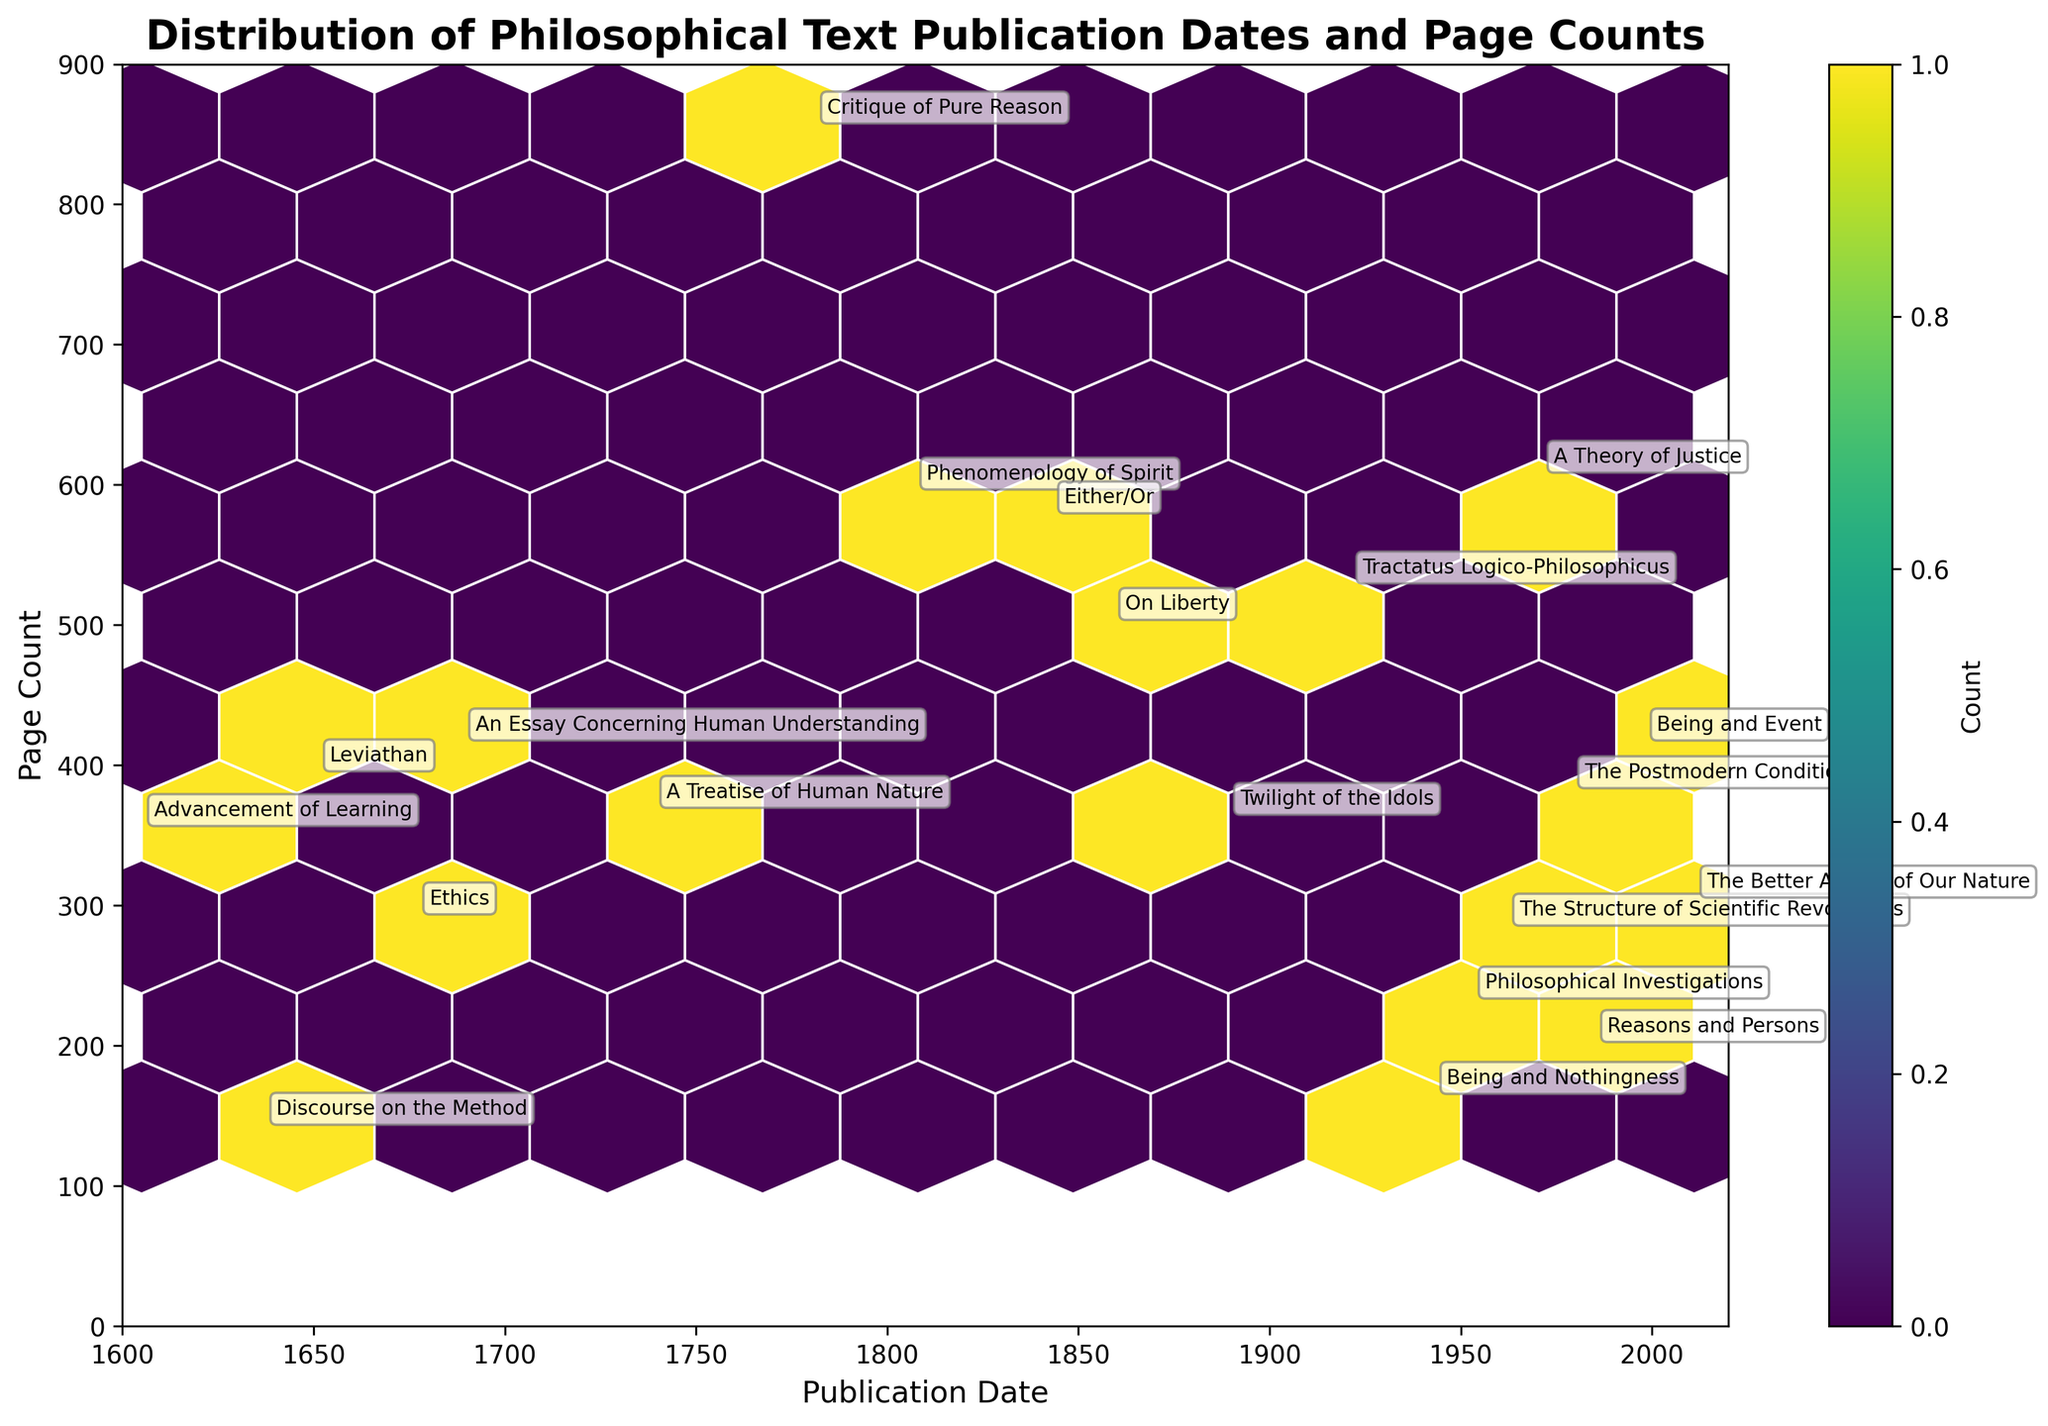What does the plot represent? The plot title is "Distribution of Philosophical Text Publication Dates and Page Counts." It indicates that this hexbin plot visualizes the relationship between publication dates and page counts of various philosophical texts. The axes labels are "Publication Date" and "Page Count," clearly denoting what each axis represents.
Answer: It represents the distribution of philosophical text publication dates and page counts How many texts were published before 1700? Observe the x-axis range from 1600 to 1700 and count the text annotation labels within this area. Specifically, there are "Advancement of Learning," "Discourse on the Method," "Leviathan," and "Ethics."
Answer: 4 Which text has the highest page count and what is it? Look for the data point on the y-axis with the highest value. Based on the text annotations, "Critique of Pure Reason" reaches about 856 pages, which is the highest on the plot.
Answer: Critique of Pure Reason What is the average publication date for texts with more than 400 pages? Identify the texts with page counts greater than 400: "An Essay Concerning Human Understanding" (1689), "Critique of Pure Reason" (1781), "Phenomenology of Spirit" (1807), "Either/Or" (1843), "A Theory of Justice" (1971), and "Being and Event" (1998). Calculate their average publication date: (1689 + 1781 + 1807 + 1843 + 1971 + 1998) / 6 = 1858.17.
Answer: 1858 What specific years have the highest concentration of published texts? The plot's density would show darker or more concentrated hexagons indicating clusters of texts published in nearby years. By examining the color gradient, one could determine the specific years, particularly around 1800-1850 and the 1900s towards the present.
Answer: Around 1800-1850 and 1900-2000 Are there more texts published after 1900 or before 1900? Count the number of hexagons (or text labels) before and after 1900. Using the annotated titles counts: Before 1900: 10 and After 1900: 10.
Answer: Same number, 10 each Which period saw texts with the highest variance in page count? Compare the spread on the y-axis across different periods' clusters. The group from around 1700-1850 shows a wide variance (140 to over 800 pages), indicating high variance in page counts.
Answer: 1700-1850 Is there a general trend between publication date and page count? Observe the scatter and binning pattern, noting any tendency or slope. Earlier works (<1800) tend to have lower page counts, whereas, post-1800, there is a tendency towards higher page counts, suggesting an increasing trend in page counts over time.
Answer: Increasing trend over time What is the median page count of texts published in the 20th century (1900-2000)? Identify the page counts for texts published in the 20th century: "Twilight of the Idols" (363), "Tractatus Logico-Philosophicus" (528), "Being and Nothingness" (164), "Philosophical Investigations" (232), "The Structure of Scientific Revolutions" (284), "A Theory of Justice" (607), "The Postmodern Condition" (382). Arrange these numbers: 164, 232, 284, 363, 382, 528, 607. The middle value (median) is 363.
Answer: 363 